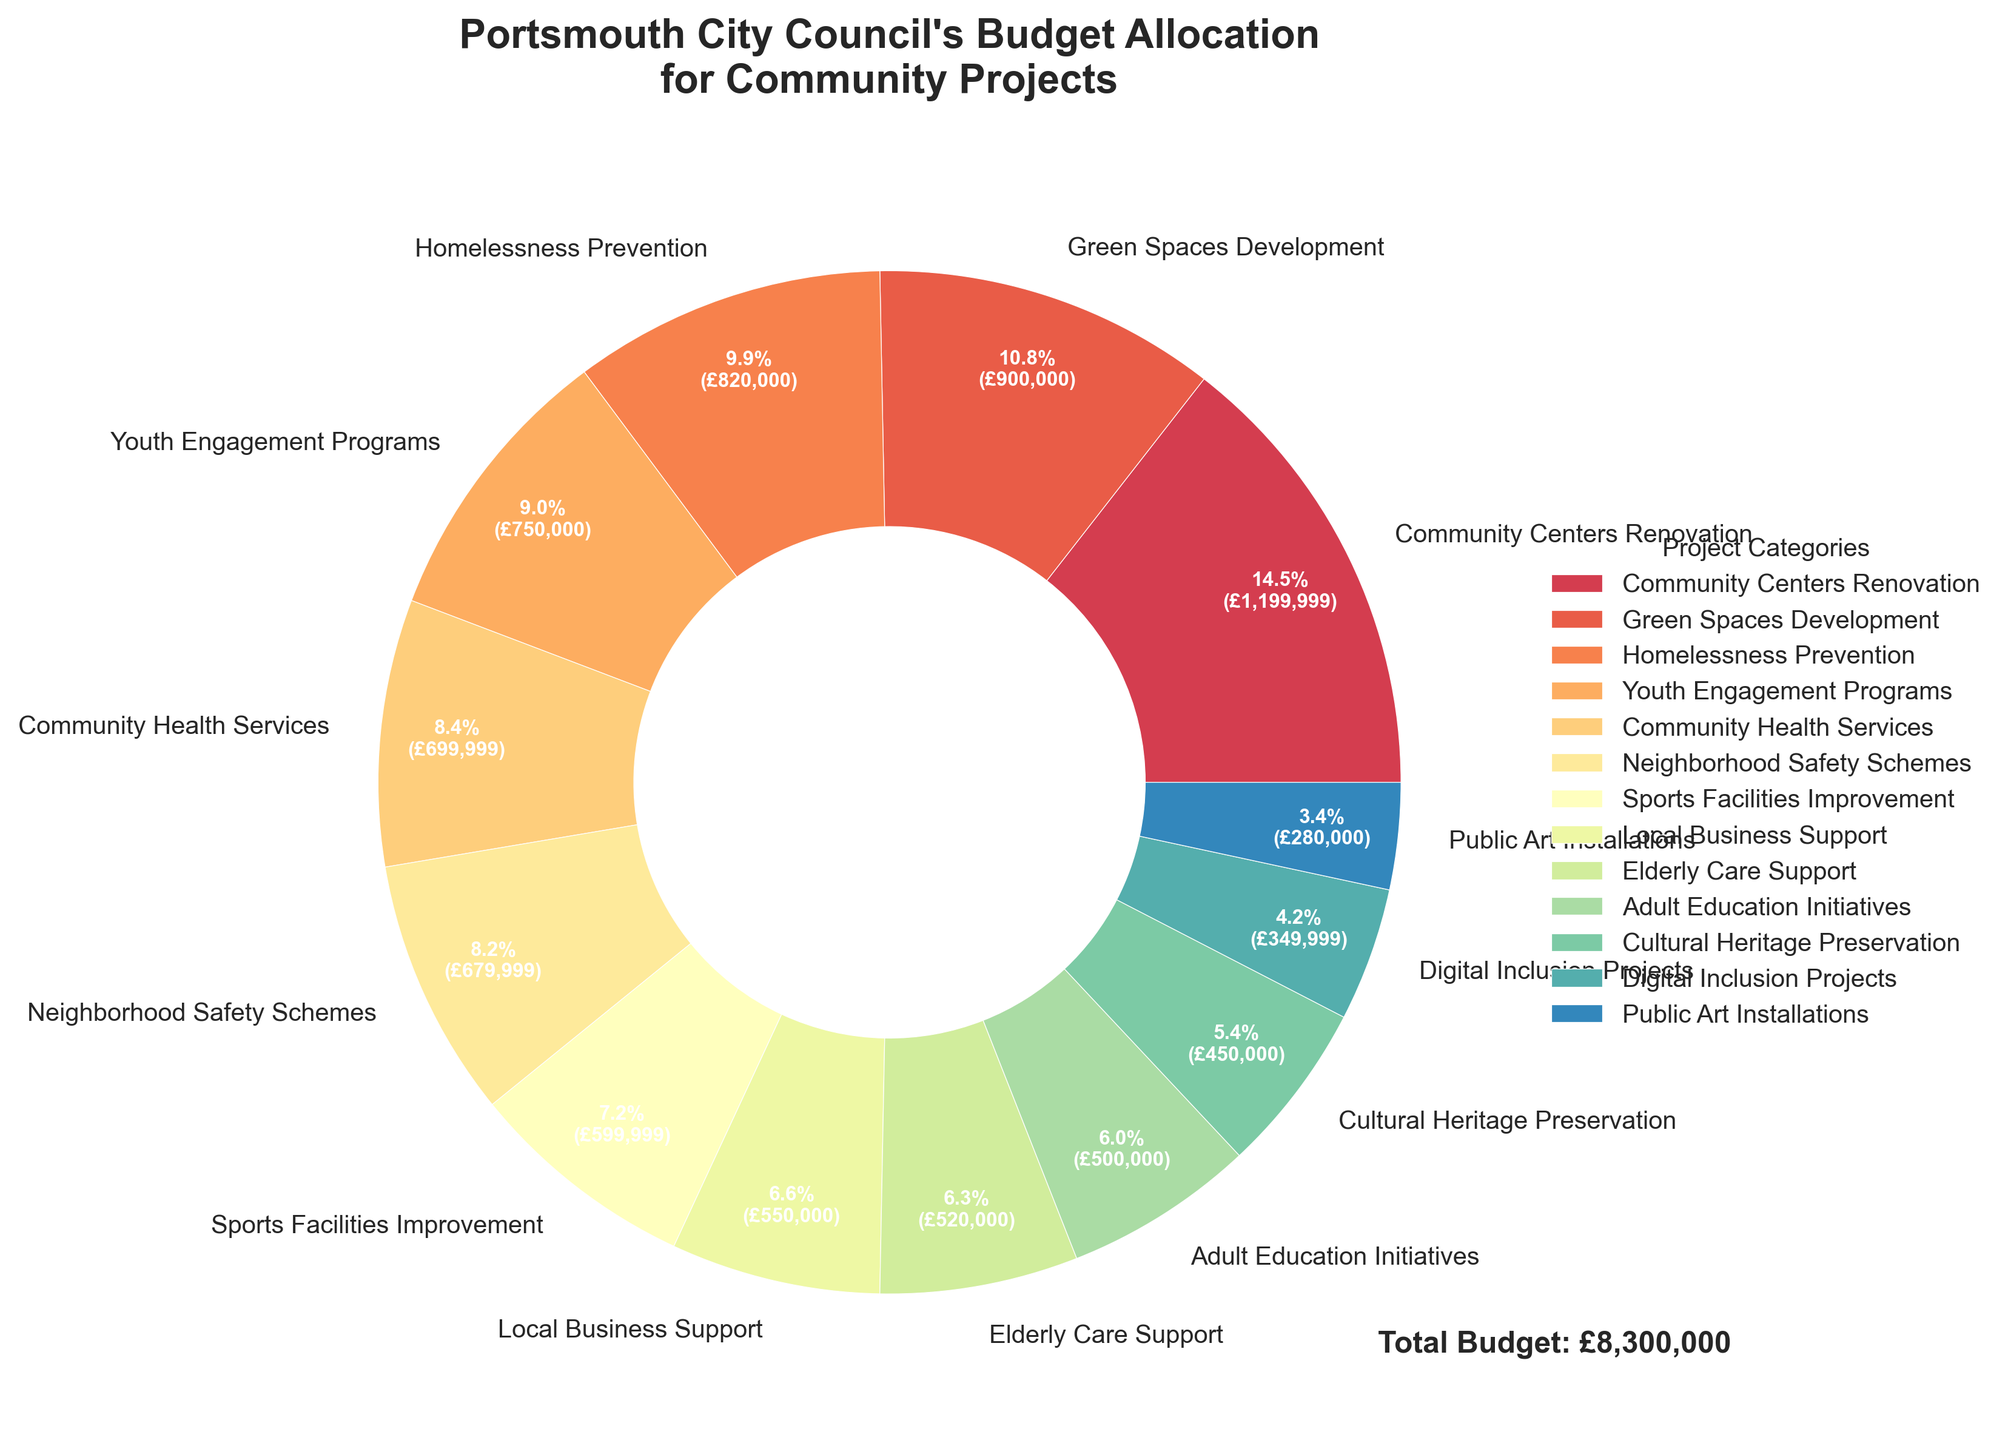Which project category received the highest budget allocation? The highest budget allocation is the segment that has the largest area (or arc length) on the pie chart. Identify it by looking at the sector with the largest percentage and amount.
Answer: Community Centers Renovation What percentage of the budget is allocated to Youth Engagement Programs? Locate the segment labeled "Youth Engagement Programs" on the pie chart and read the percentage displayed within the segment.
Answer: 12.5% What is the combined budget allocation for Green Spaces Development and Adult Education Initiatives? Find the budget for both projects, add them together: £900,000 (Green Spaces) + £500,000 (Adult Education).
Answer: £1,400,000 How many categories received more than 10% of the total budget? Identify all segments with a percentage label higher than 10% and count them.
Answer: 3 categories Which project category has the smallest budget allocation? The smallest budget allocation is the segment with the smallest area (or arc length) on the pie chart. Identify it by looking at the sector with the smallest percentage and amount.
Answer: Public Art Installations How does the budget allocation for Neighborhood Safety Schemes compare to Community Health Services? Find both segments and compare their budget allocations. Neighborhood Safety Schemes has larger allocation than Community Health Services.
Answer: Neighborhood Safety Schemes has more What is the total budget allocated to projects related to health and elderly care (Community Health Services and Elderly Care Support)? Sum the budgets for these two categories: £700,000 (Community Health Services) + £520,000 (Elderly Care Support).
Answer: £1,220,000 What percent of the total budget is allocated to Digital Inclusion Projects? Locate the segment labeled "Digital Inclusion Projects" and read the percentage displayed within the segment.
Answer: 5.8% Is the budget allocation for Local Business Support greater than that for Cultural Heritage Preservation? Compare the segments for both categories to check which one has a larger percentage and amount.
Answer: Yes Which project category is represented in the blue color in the chart? Identify the segment colored blue and read its label.
Answer: Homelessness Prevention 